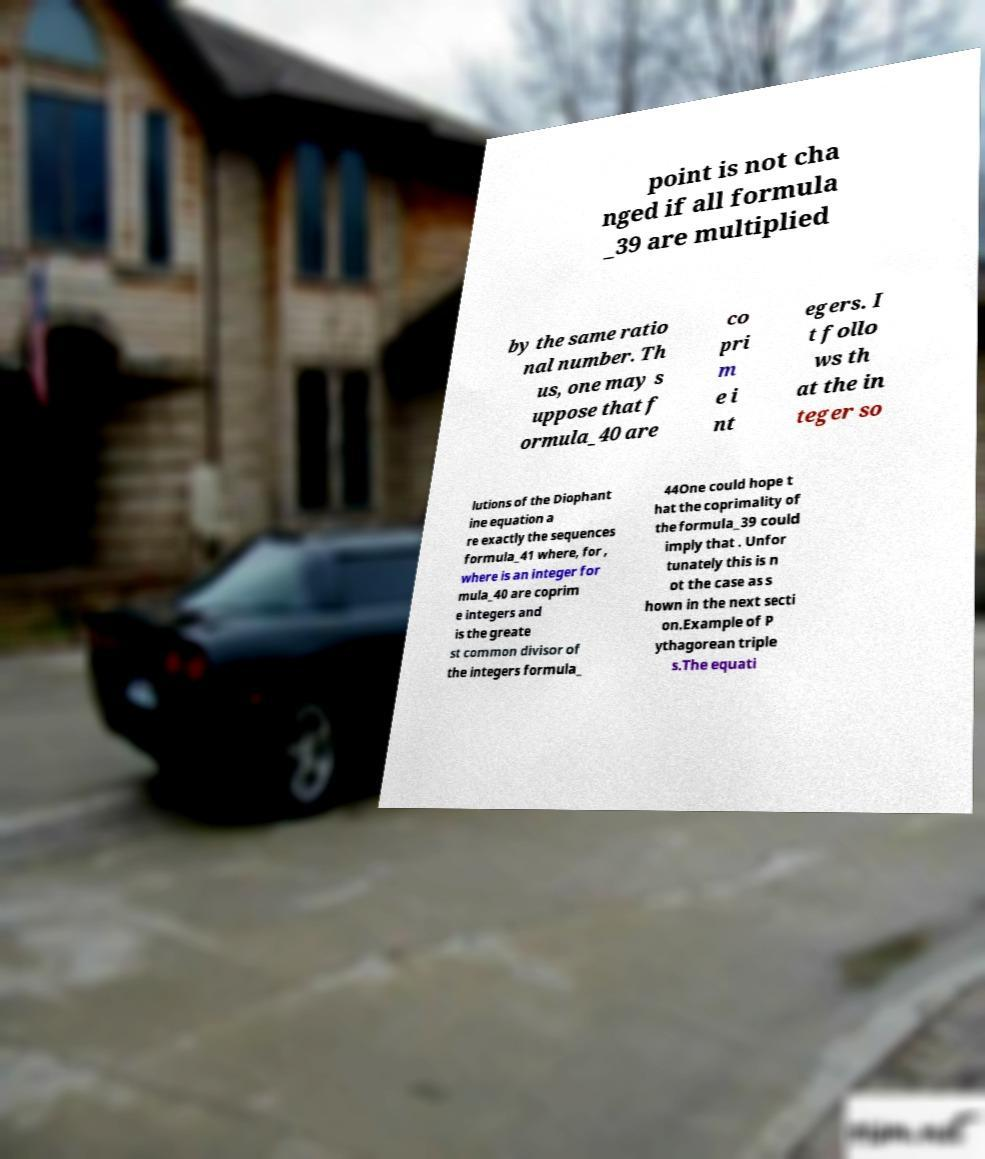Please read and relay the text visible in this image. What does it say? point is not cha nged if all formula _39 are multiplied by the same ratio nal number. Th us, one may s uppose that f ormula_40 are co pri m e i nt egers. I t follo ws th at the in teger so lutions of the Diophant ine equation a re exactly the sequences formula_41 where, for , where is an integer for mula_40 are coprim e integers and is the greate st common divisor of the integers formula_ 44One could hope t hat the coprimality of the formula_39 could imply that . Unfor tunately this is n ot the case as s hown in the next secti on.Example of P ythagorean triple s.The equati 